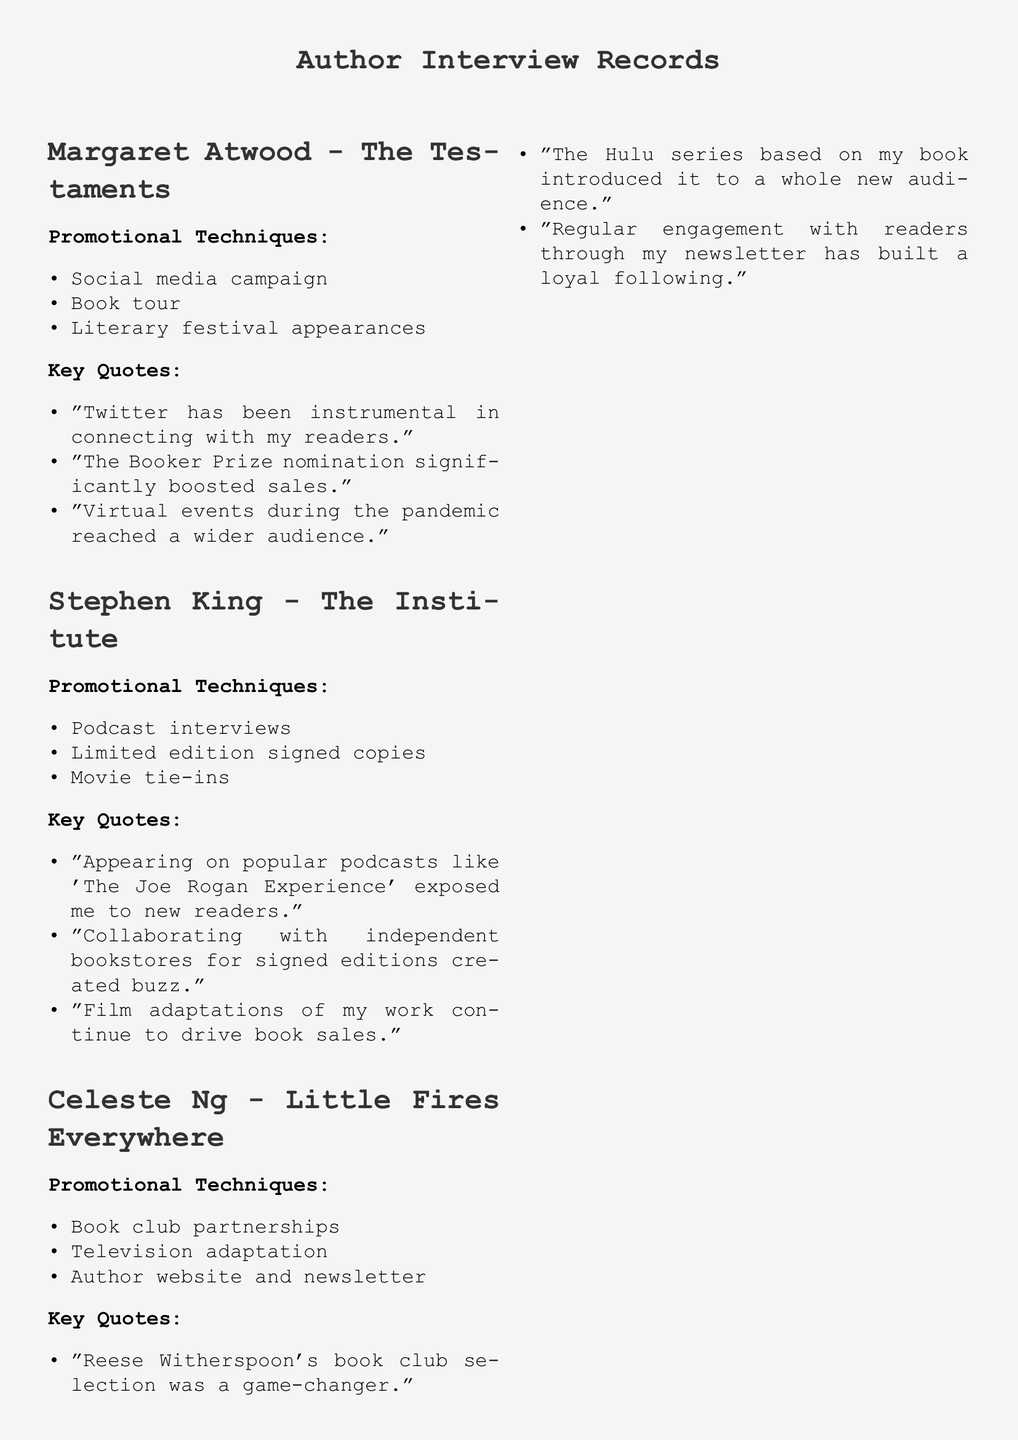what promotional technique did Stephen King use that involved signed copies? The document states that he used limited edition signed copies as one of his promotional techniques.
Answer: limited edition signed copies which book was selected by Reese Witherspoon's book club? Celeste Ng mentions that Reese Witherspoon's selection was a game-changer for her book, indicating it was "Little Fires Everywhere."
Answer: Little Fires Everywhere what is one platform that Margaret Atwood credited for connecting with her readers? The document indicates that Atwood mentioned Twitter as an instrumental platform for connecting with her readers.
Answer: Twitter what promotional trend emphasizes the use of personal storytelling? The document lists "Emphasis on author branding and personal storytelling" as a promotional trend.
Answer: author branding and personal storytelling how many authors are discussed in the document? The document includes discussions from three authors: Margaret Atwood, Stephen King, and Celeste Ng.
Answer: three which promotional technique is mentioned for Celeste Ng aside from book club partnerships? The document states that Celeste Ng also used a television adaptation as a promotional technique.
Answer: television adaptation what was a significant event that boosted Margaret Atwood's book sales? Atwood indicated that her nomination for the Booker Prize significantly boosted her sales.
Answer: Booker Prize nomination what type of content is increasingly used in promotional trends according to the document? The document mentions the use of video content and book trailers as a promotional trend.
Answer: video content and book trailers what strategy did Stephen King mention that continues to drive book sales? King stated that film adaptations of his work continue to drive sales, highlighting this as part of his strategy.
Answer: Film adaptations 